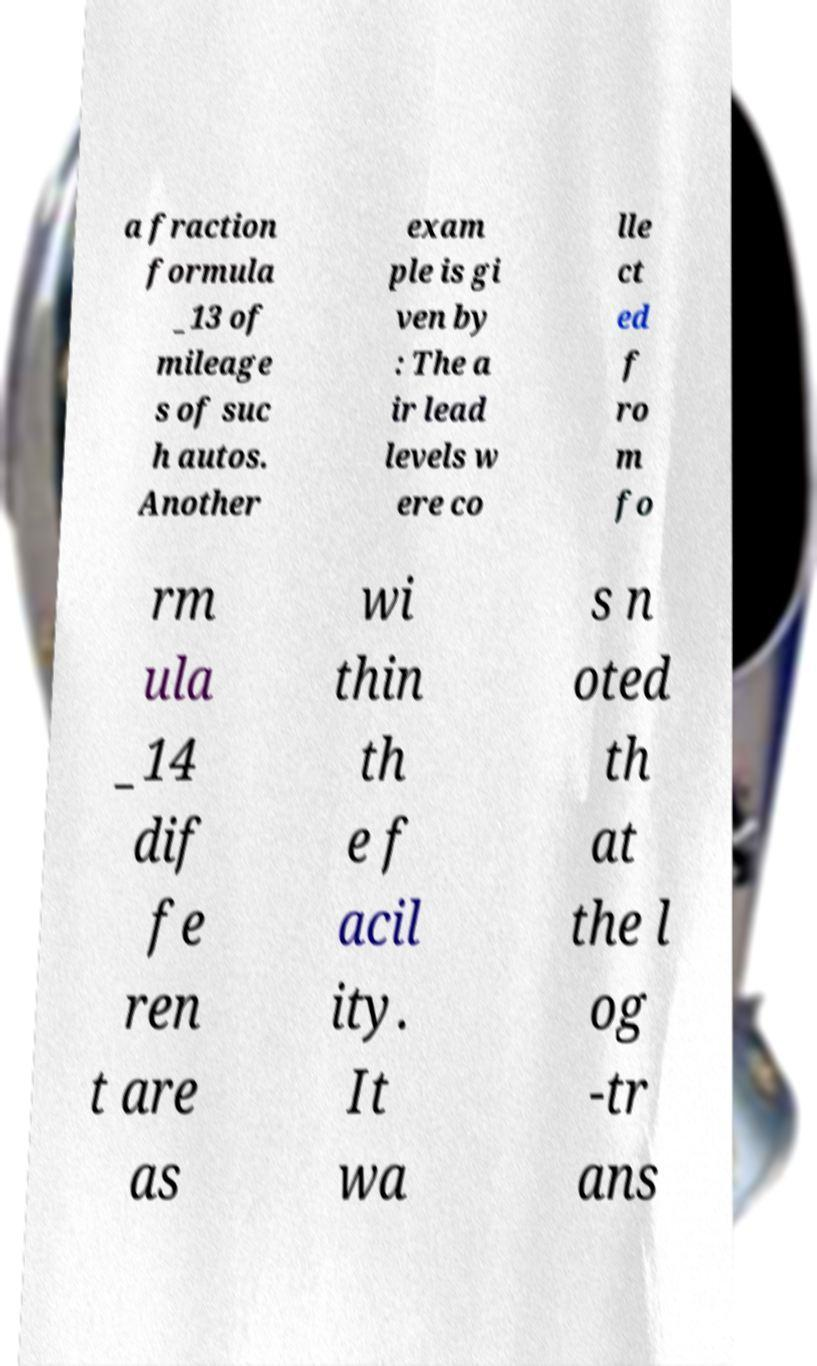There's text embedded in this image that I need extracted. Can you transcribe it verbatim? a fraction formula _13 of mileage s of suc h autos. Another exam ple is gi ven by : The a ir lead levels w ere co lle ct ed f ro m fo rm ula _14 dif fe ren t are as wi thin th e f acil ity. It wa s n oted th at the l og -tr ans 